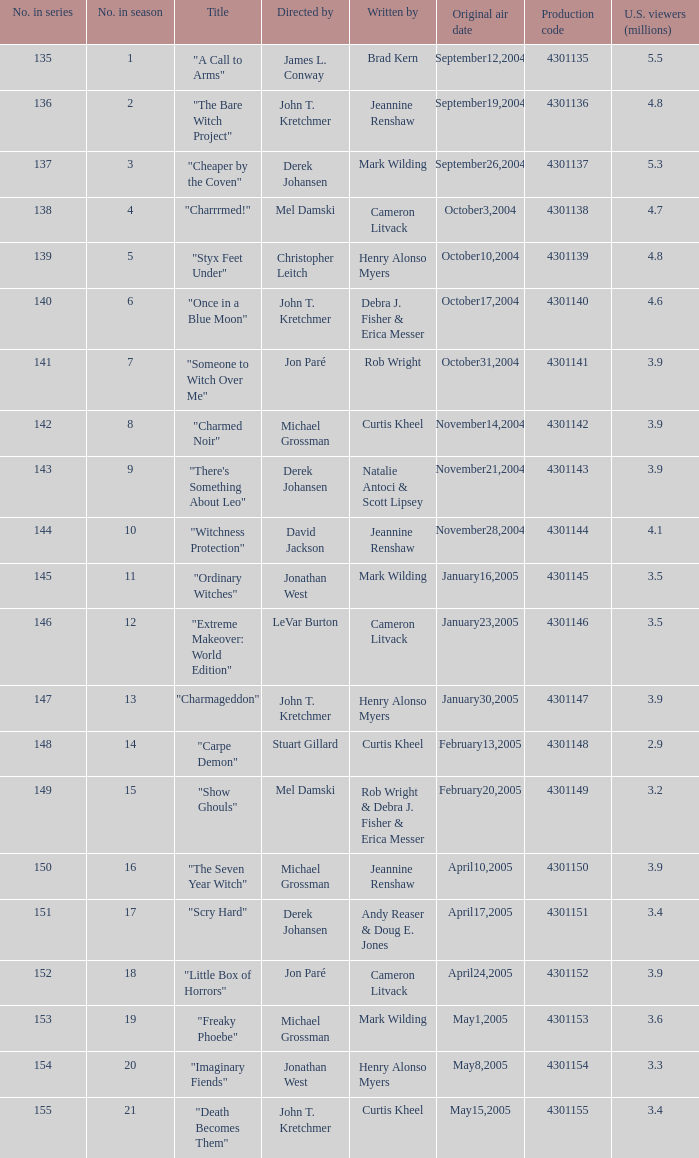What is the no in series when rob wright & debra j. fisher & erica messer were the writers? 149.0. 